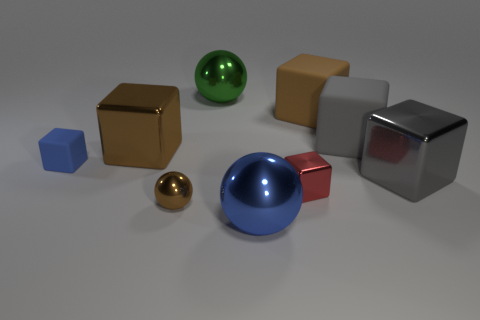Subtract all red blocks. How many blocks are left? 5 Subtract all small red metal blocks. How many blocks are left? 5 Subtract all blue blocks. Subtract all gray cylinders. How many blocks are left? 5 Add 1 small things. How many objects exist? 10 Subtract all spheres. How many objects are left? 6 Subtract all small metal balls. Subtract all blue matte cubes. How many objects are left? 7 Add 5 gray blocks. How many gray blocks are left? 7 Add 1 small green rubber balls. How many small green rubber balls exist? 1 Subtract 1 blue balls. How many objects are left? 8 